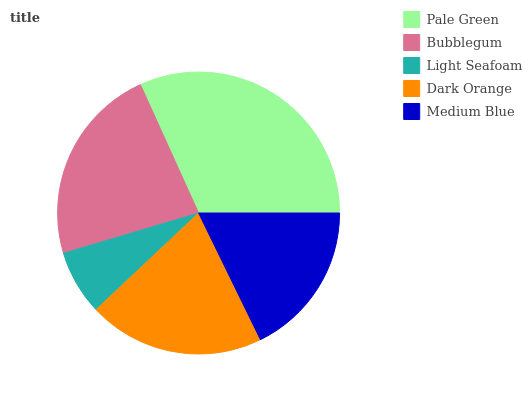Is Light Seafoam the minimum?
Answer yes or no. Yes. Is Pale Green the maximum?
Answer yes or no. Yes. Is Bubblegum the minimum?
Answer yes or no. No. Is Bubblegum the maximum?
Answer yes or no. No. Is Pale Green greater than Bubblegum?
Answer yes or no. Yes. Is Bubblegum less than Pale Green?
Answer yes or no. Yes. Is Bubblegum greater than Pale Green?
Answer yes or no. No. Is Pale Green less than Bubblegum?
Answer yes or no. No. Is Dark Orange the high median?
Answer yes or no. Yes. Is Dark Orange the low median?
Answer yes or no. Yes. Is Light Seafoam the high median?
Answer yes or no. No. Is Pale Green the low median?
Answer yes or no. No. 